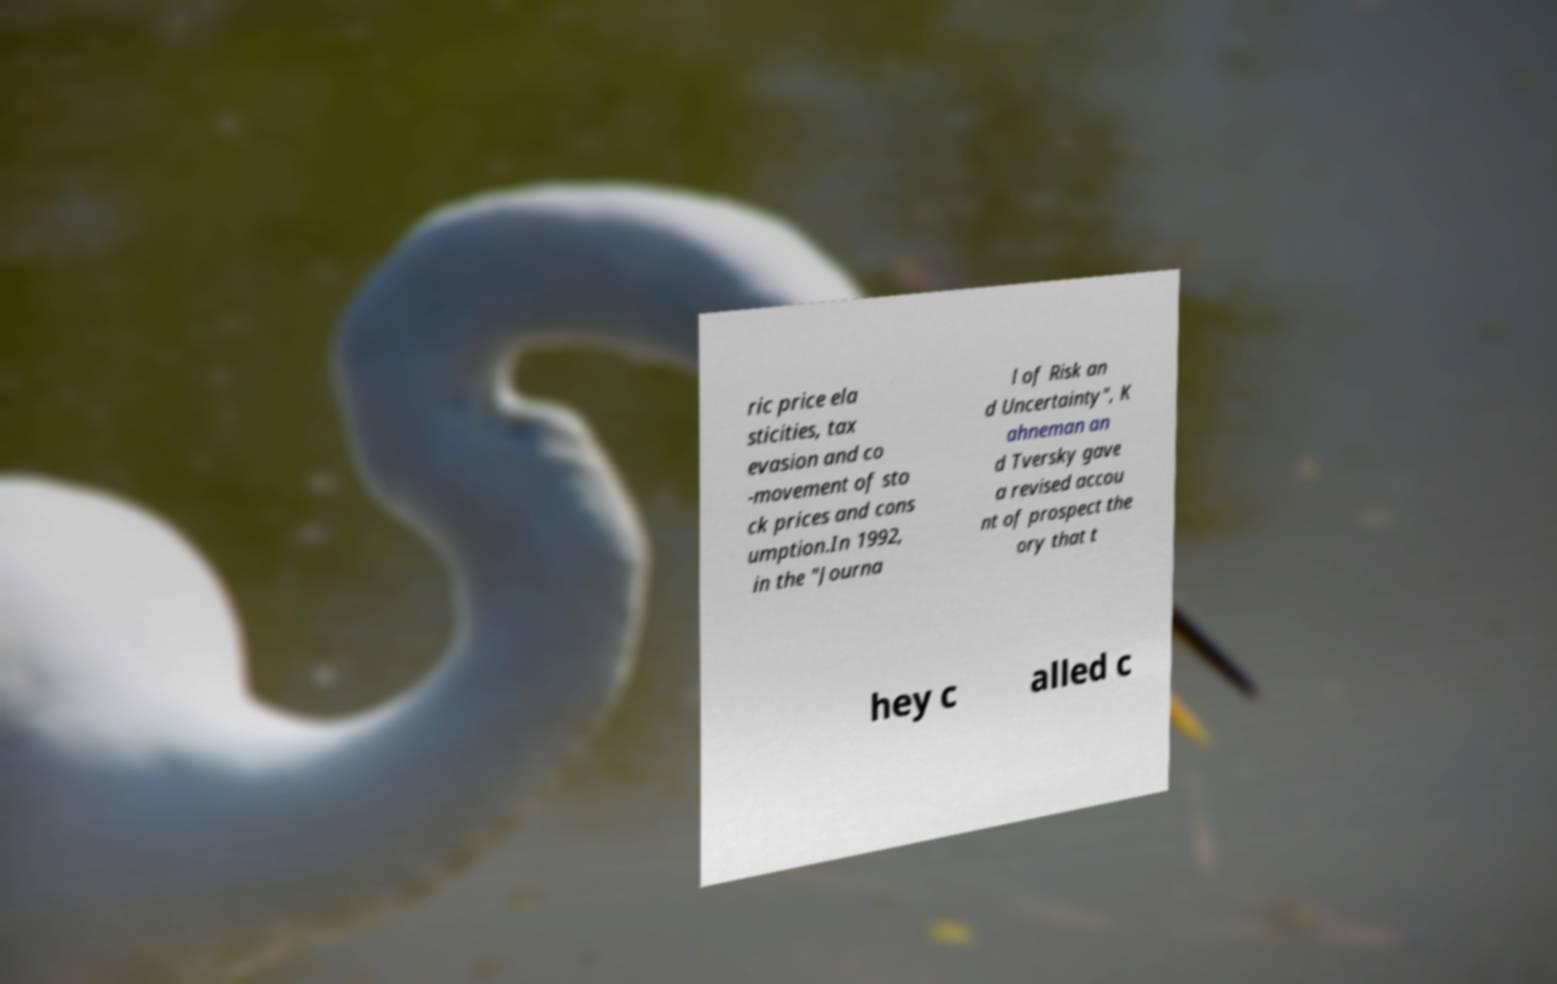For documentation purposes, I need the text within this image transcribed. Could you provide that? ric price ela sticities, tax evasion and co -movement of sto ck prices and cons umption.In 1992, in the "Journa l of Risk an d Uncertainty", K ahneman an d Tversky gave a revised accou nt of prospect the ory that t hey c alled c 